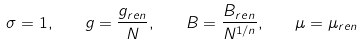Convert formula to latex. <formula><loc_0><loc_0><loc_500><loc_500>\sigma = 1 , \quad g = \frac { g _ { r e n } } N , \quad B = \frac { B _ { r e n } } { N ^ { 1 / n } } , \quad \mu = \mu _ { r e n }</formula> 